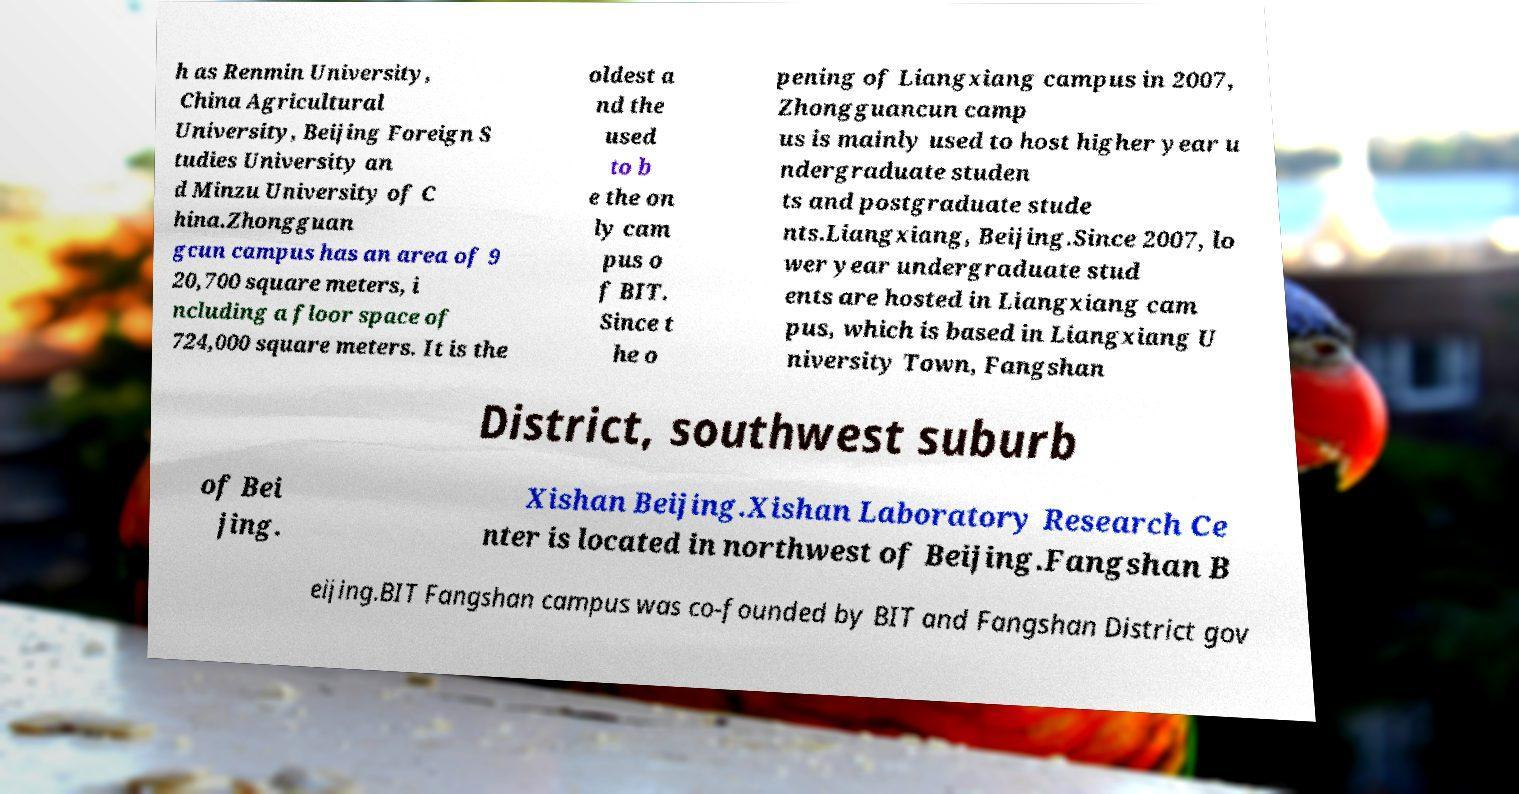For documentation purposes, I need the text within this image transcribed. Could you provide that? h as Renmin University, China Agricultural University, Beijing Foreign S tudies University an d Minzu University of C hina.Zhongguan gcun campus has an area of 9 20,700 square meters, i ncluding a floor space of 724,000 square meters. It is the oldest a nd the used to b e the on ly cam pus o f BIT. Since t he o pening of Liangxiang campus in 2007, Zhongguancun camp us is mainly used to host higher year u ndergraduate studen ts and postgraduate stude nts.Liangxiang, Beijing.Since 2007, lo wer year undergraduate stud ents are hosted in Liangxiang cam pus, which is based in Liangxiang U niversity Town, Fangshan District, southwest suburb of Bei jing. Xishan Beijing.Xishan Laboratory Research Ce nter is located in northwest of Beijing.Fangshan B eijing.BIT Fangshan campus was co-founded by BIT and Fangshan District gov 